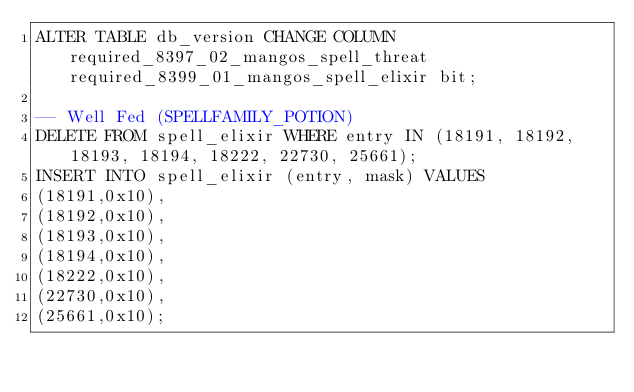<code> <loc_0><loc_0><loc_500><loc_500><_SQL_>ALTER TABLE db_version CHANGE COLUMN required_8397_02_mangos_spell_threat required_8399_01_mangos_spell_elixir bit;

-- Well Fed (SPELLFAMILY_POTION)
DELETE FROM spell_elixir WHERE entry IN (18191, 18192, 18193, 18194, 18222, 22730, 25661);
INSERT INTO spell_elixir (entry, mask) VALUES
(18191,0x10),
(18192,0x10),
(18193,0x10),
(18194,0x10),
(18222,0x10),
(22730,0x10),
(25661,0x10);
</code> 